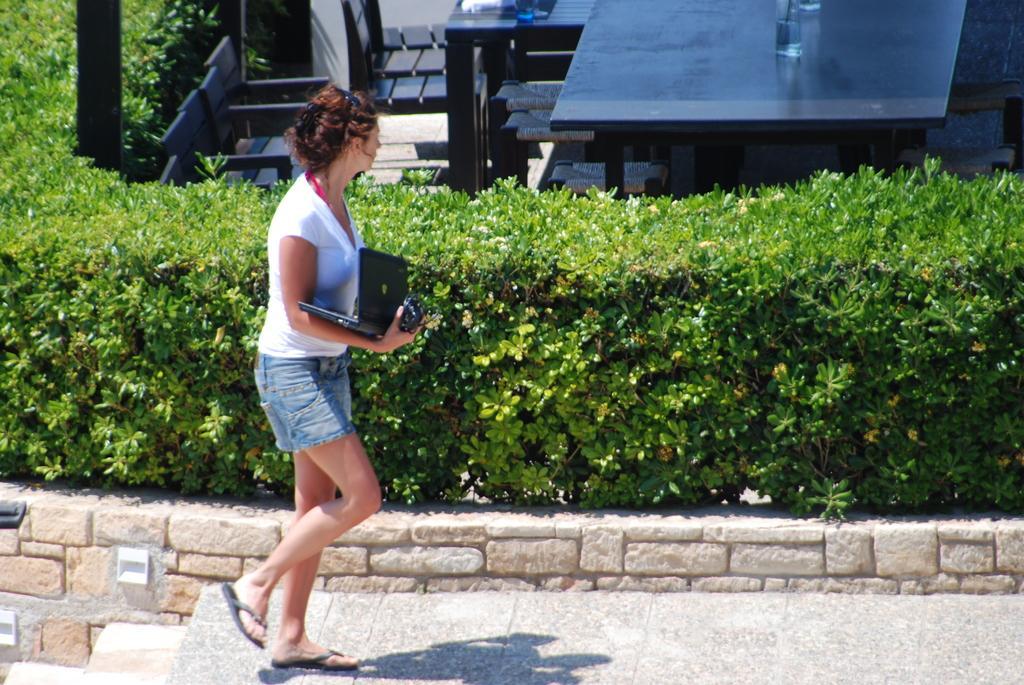Describe this image in one or two sentences. In this picture we can see a woman in the white t shirt. She is walking on the walkway and holding a laptop and an object. Behind the woman there is a hedge, chairs and some objects. 